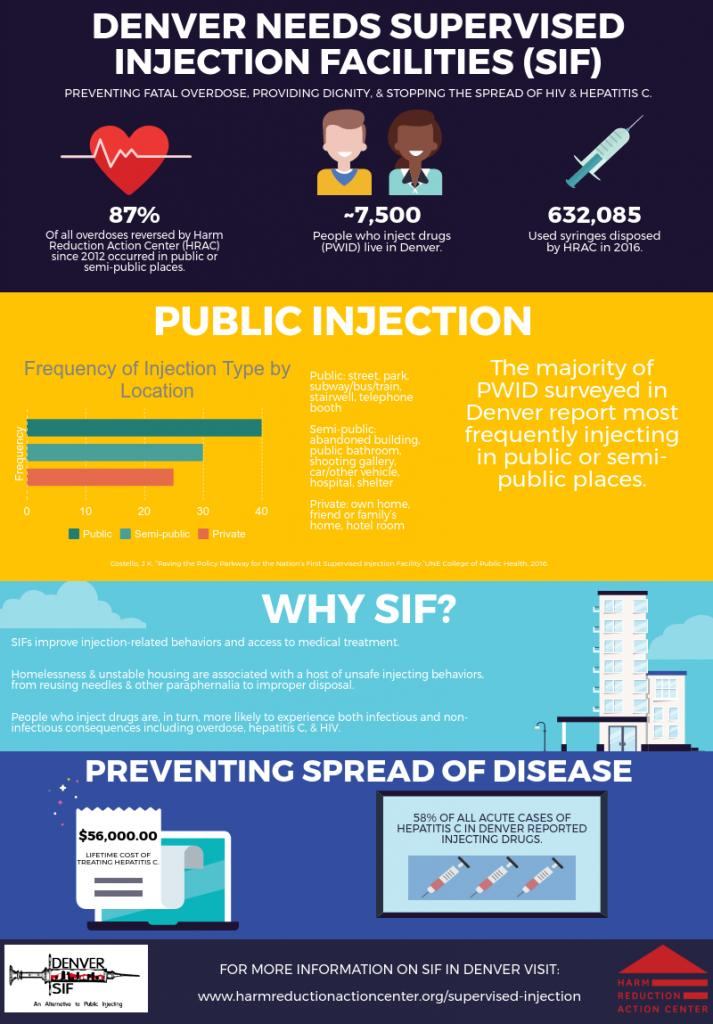Outline some significant characteristics in this image. The color of hear is red. The location of a hotel room is private. The location of the shooting gallery is semi-public, and it is a place where shooting games are played. The frequency is the second highest in a location that is semi-public. The location of a telephone booth is public. 